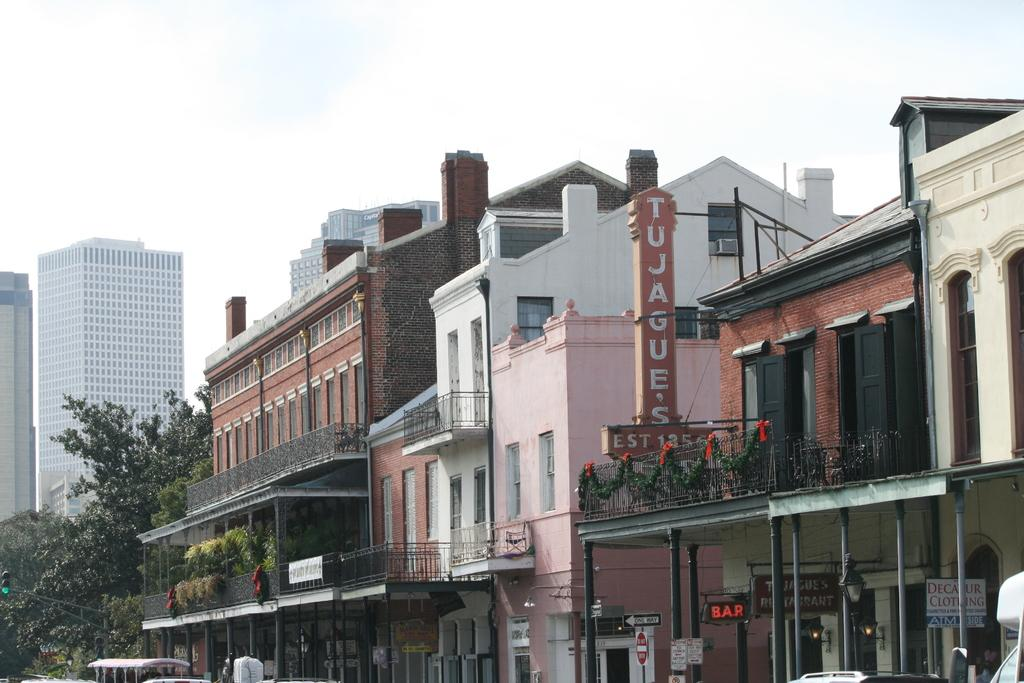What is located in the center of the image? There are buildings in the center of the image. What type of vegetation is on the left side of the image? There are trees on the left side of the image. What is visible at the top of the image? The sky is visible at the top of the image. How many steps are there in the image? There is no mention of steps in the image, so it is not possible to determine the number of steps. Can you locate a map in the image? There is no map present in the image. 